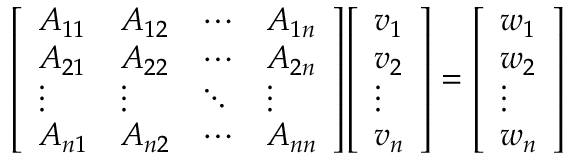<formula> <loc_0><loc_0><loc_500><loc_500>{ \left [ \begin{array} { l l l l } { A _ { 1 1 } } & { A _ { 1 2 } } & { \cdots } & { A _ { 1 n } } \\ { A _ { 2 1 } } & { A _ { 2 2 } } & { \cdots } & { A _ { 2 n } } \\ { \vdots } & { \vdots } & { \ddots } & { \vdots } \\ { A _ { n 1 } } & { A _ { n 2 } } & { \cdots } & { A _ { n n } } \end{array} \right ] } { \left [ \begin{array} { l } { v _ { 1 } } \\ { v _ { 2 } } \\ { \vdots } \\ { v _ { n } } \end{array} \right ] } = { \left [ \begin{array} { l } { w _ { 1 } } \\ { w _ { 2 } } \\ { \vdots } \\ { w _ { n } } \end{array} \right ] }</formula> 